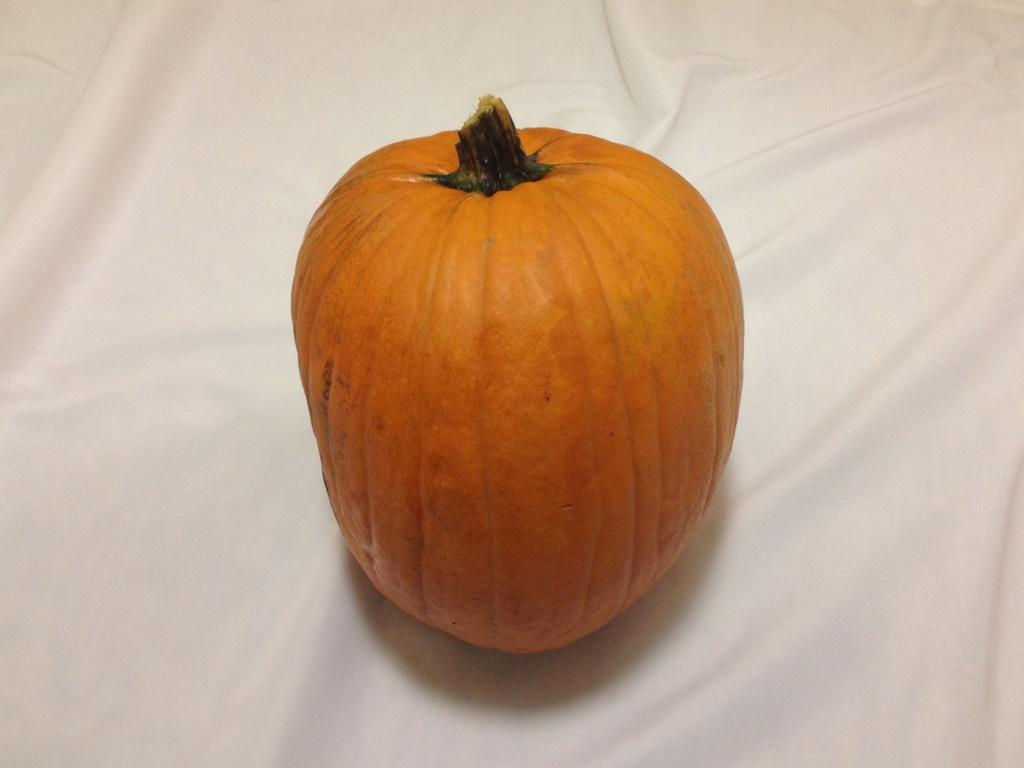What type of furniture is present in the image? There is a table in the image. What is covering the table? The table has a tablecloth on it. What object is placed on the table? There is a pumpkin on the table. What type of operation is being performed on the pumpkin in the image? There is no operation being performed on the pumpkin in the image; it is simply sitting on the table. 